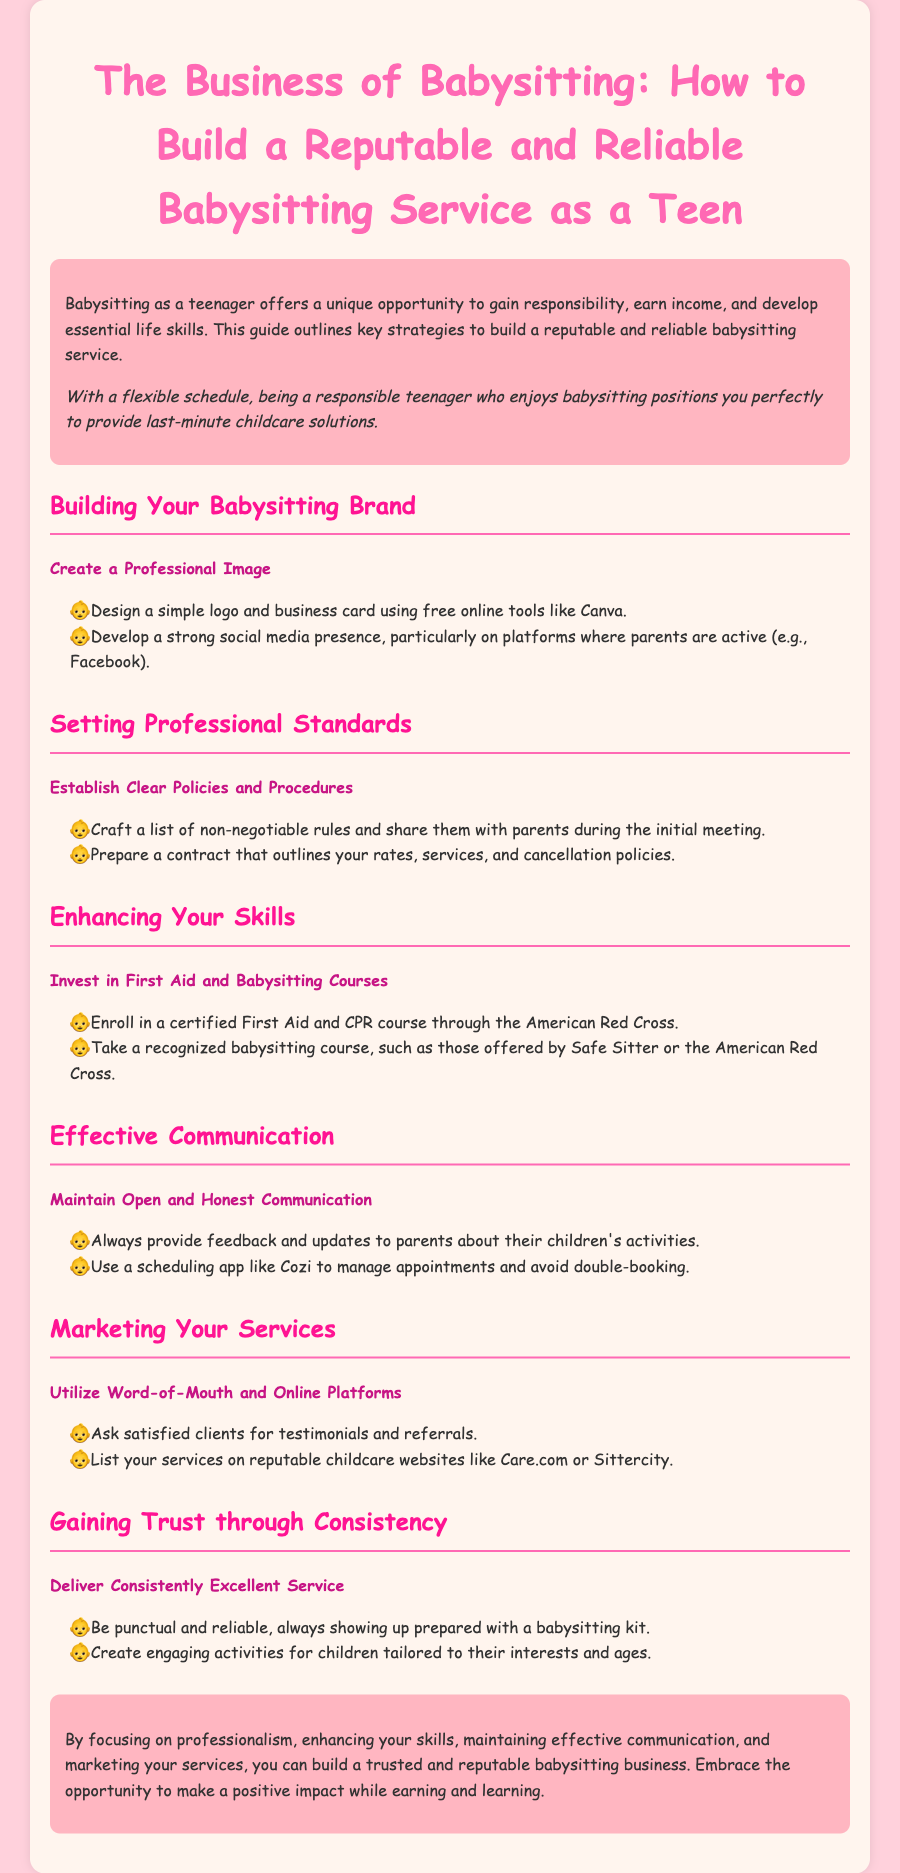What is the main opportunity offered by babysitting? The document states that babysitting as a teenager offers a unique opportunity to gain responsibility, earn income, and develop essential life skills.
Answer: Responsibility What should you create for a professional image? The document suggests designing a simple logo and business card using free online tools like Canva to create a professional image.
Answer: Logo Which organization offers certified First Aid courses? The document mentions the American Red Cross as the organization that offers certified First Aid and CPR courses.
Answer: American Red Cross What type of communication is emphasized in the document? The document emphasizes the importance of open and honest communication with parents about their children's activities.
Answer: Open communication What is one platform to list your babysitting services? The document recommends listing your services on reputable childcare websites like Care.com or Sittercity.
Answer: Care.com What are two aspects of consistency that help gain trust? The document states that punctuality and engaging activities for children are two aspects that help gain trust through consistency.
Answer: Punctuality and engaging activities 